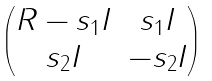Convert formula to latex. <formula><loc_0><loc_0><loc_500><loc_500>\begin{pmatrix} R - s _ { 1 } I & s _ { 1 } I \\ s _ { 2 } I & - s _ { 2 } I \end{pmatrix}</formula> 